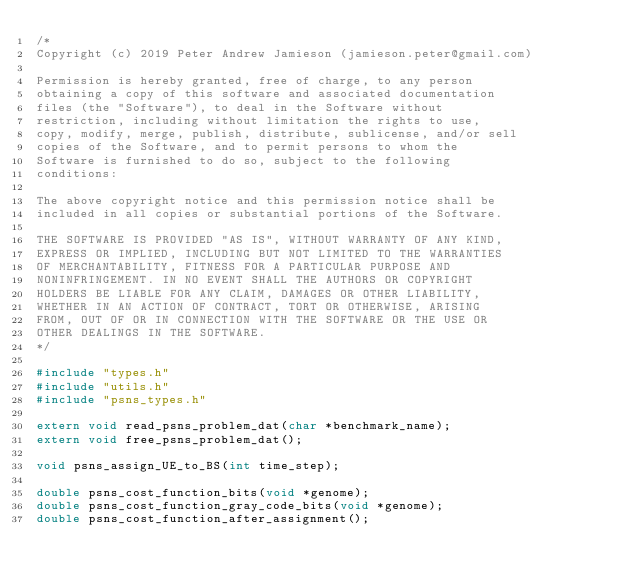Convert code to text. <code><loc_0><loc_0><loc_500><loc_500><_C_>/*
Copyright (c) 2019 Peter Andrew Jamieson (jamieson.peter@gmail.com)

Permission is hereby granted, free of charge, to any person
obtaining a copy of this software and associated documentation
files (the "Software"), to deal in the Software without
restriction, including without limitation the rights to use,
copy, modify, merge, publish, distribute, sublicense, and/or sell
copies of the Software, and to permit persons to whom the
Software is furnished to do so, subject to the following
conditions:

The above copyright notice and this permission notice shall be
included in all copies or substantial portions of the Software.

THE SOFTWARE IS PROVIDED "AS IS", WITHOUT WARRANTY OF ANY KIND,
EXPRESS OR IMPLIED, INCLUDING BUT NOT LIMITED TO THE WARRANTIES
OF MERCHANTABILITY, FITNESS FOR A PARTICULAR PURPOSE AND
NONINFRINGEMENT. IN NO EVENT SHALL THE AUTHORS OR COPYRIGHT
HOLDERS BE LIABLE FOR ANY CLAIM, DAMAGES OR OTHER LIABILITY,
WHETHER IN AN ACTION OF CONTRACT, TORT OR OTHERWISE, ARISING
FROM, OUT OF OR IN CONNECTION WITH THE SOFTWARE OR THE USE OR
OTHER DEALINGS IN THE SOFTWARE.
*/

#include "types.h"
#include "utils.h"
#include "psns_types.h"

extern void read_psns_problem_dat(char *benchmark_name);
extern void free_psns_problem_dat();

void psns_assign_UE_to_BS(int time_step);

double psns_cost_function_bits(void *genome);
double psns_cost_function_gray_code_bits(void *genome);
double psns_cost_function_after_assignment();

</code> 